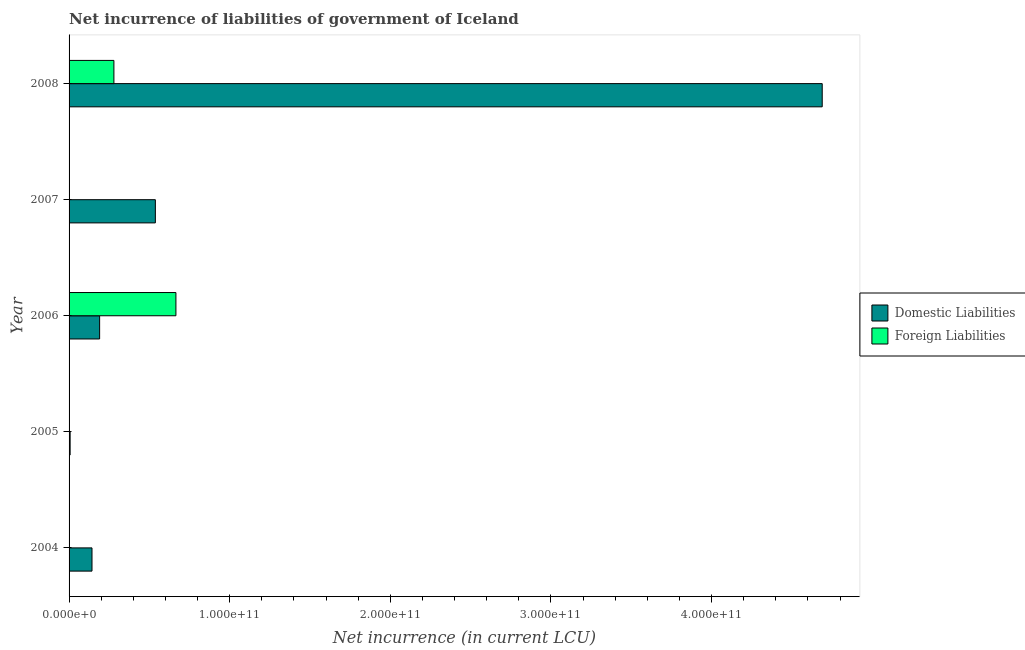Are the number of bars per tick equal to the number of legend labels?
Your answer should be compact. No. Are the number of bars on each tick of the Y-axis equal?
Provide a short and direct response. No. How many bars are there on the 3rd tick from the top?
Make the answer very short. 2. How many bars are there on the 2nd tick from the bottom?
Your response must be concise. 1. What is the net incurrence of domestic liabilities in 2007?
Make the answer very short. 5.37e+1. Across all years, what is the maximum net incurrence of foreign liabilities?
Make the answer very short. 6.65e+1. Across all years, what is the minimum net incurrence of domestic liabilities?
Your answer should be very brief. 6.52e+08. What is the total net incurrence of foreign liabilities in the graph?
Keep it short and to the point. 9.44e+1. What is the difference between the net incurrence of domestic liabilities in 2006 and that in 2007?
Offer a very short reply. -3.47e+1. What is the difference between the net incurrence of domestic liabilities in 2004 and the net incurrence of foreign liabilities in 2008?
Provide a succinct answer. -1.36e+1. What is the average net incurrence of domestic liabilities per year?
Make the answer very short. 1.11e+11. In the year 2008, what is the difference between the net incurrence of domestic liabilities and net incurrence of foreign liabilities?
Your response must be concise. 4.41e+11. What is the ratio of the net incurrence of foreign liabilities in 2006 to that in 2008?
Your answer should be compact. 2.38. Is the net incurrence of domestic liabilities in 2004 less than that in 2006?
Offer a very short reply. Yes. Is the difference between the net incurrence of foreign liabilities in 2006 and 2008 greater than the difference between the net incurrence of domestic liabilities in 2006 and 2008?
Provide a short and direct response. Yes. What is the difference between the highest and the second highest net incurrence of domestic liabilities?
Give a very brief answer. 4.15e+11. What is the difference between the highest and the lowest net incurrence of foreign liabilities?
Provide a short and direct response. 6.65e+1. Are all the bars in the graph horizontal?
Your answer should be very brief. Yes. What is the difference between two consecutive major ticks on the X-axis?
Keep it short and to the point. 1.00e+11. Does the graph contain any zero values?
Your response must be concise. Yes. Where does the legend appear in the graph?
Ensure brevity in your answer.  Center right. What is the title of the graph?
Your answer should be compact. Net incurrence of liabilities of government of Iceland. Does "Private consumption" appear as one of the legend labels in the graph?
Offer a terse response. No. What is the label or title of the X-axis?
Your response must be concise. Net incurrence (in current LCU). What is the Net incurrence (in current LCU) in Domestic Liabilities in 2004?
Make the answer very short. 1.43e+1. What is the Net incurrence (in current LCU) of Foreign Liabilities in 2004?
Your response must be concise. 0. What is the Net incurrence (in current LCU) of Domestic Liabilities in 2005?
Give a very brief answer. 6.52e+08. What is the Net incurrence (in current LCU) in Domestic Liabilities in 2006?
Provide a succinct answer. 1.90e+1. What is the Net incurrence (in current LCU) of Foreign Liabilities in 2006?
Ensure brevity in your answer.  6.65e+1. What is the Net incurrence (in current LCU) in Domestic Liabilities in 2007?
Provide a short and direct response. 5.37e+1. What is the Net incurrence (in current LCU) of Domestic Liabilities in 2008?
Offer a terse response. 4.69e+11. What is the Net incurrence (in current LCU) of Foreign Liabilities in 2008?
Ensure brevity in your answer.  2.79e+1. Across all years, what is the maximum Net incurrence (in current LCU) in Domestic Liabilities?
Your answer should be compact. 4.69e+11. Across all years, what is the maximum Net incurrence (in current LCU) of Foreign Liabilities?
Give a very brief answer. 6.65e+1. Across all years, what is the minimum Net incurrence (in current LCU) in Domestic Liabilities?
Make the answer very short. 6.52e+08. What is the total Net incurrence (in current LCU) in Domestic Liabilities in the graph?
Ensure brevity in your answer.  5.57e+11. What is the total Net incurrence (in current LCU) in Foreign Liabilities in the graph?
Offer a very short reply. 9.44e+1. What is the difference between the Net incurrence (in current LCU) in Domestic Liabilities in 2004 and that in 2005?
Offer a very short reply. 1.36e+1. What is the difference between the Net incurrence (in current LCU) of Domestic Liabilities in 2004 and that in 2006?
Make the answer very short. -4.75e+09. What is the difference between the Net incurrence (in current LCU) in Domestic Liabilities in 2004 and that in 2007?
Provide a succinct answer. -3.95e+1. What is the difference between the Net incurrence (in current LCU) of Domestic Liabilities in 2004 and that in 2008?
Give a very brief answer. -4.55e+11. What is the difference between the Net incurrence (in current LCU) of Domestic Liabilities in 2005 and that in 2006?
Make the answer very short. -1.84e+1. What is the difference between the Net incurrence (in current LCU) of Domestic Liabilities in 2005 and that in 2007?
Provide a short and direct response. -5.31e+1. What is the difference between the Net incurrence (in current LCU) of Domestic Liabilities in 2005 and that in 2008?
Offer a terse response. -4.68e+11. What is the difference between the Net incurrence (in current LCU) in Domestic Liabilities in 2006 and that in 2007?
Make the answer very short. -3.47e+1. What is the difference between the Net incurrence (in current LCU) of Domestic Liabilities in 2006 and that in 2008?
Ensure brevity in your answer.  -4.50e+11. What is the difference between the Net incurrence (in current LCU) in Foreign Liabilities in 2006 and that in 2008?
Offer a terse response. 3.86e+1. What is the difference between the Net incurrence (in current LCU) in Domestic Liabilities in 2007 and that in 2008?
Your response must be concise. -4.15e+11. What is the difference between the Net incurrence (in current LCU) in Domestic Liabilities in 2004 and the Net incurrence (in current LCU) in Foreign Liabilities in 2006?
Provide a succinct answer. -5.23e+1. What is the difference between the Net incurrence (in current LCU) of Domestic Liabilities in 2004 and the Net incurrence (in current LCU) of Foreign Liabilities in 2008?
Offer a very short reply. -1.36e+1. What is the difference between the Net incurrence (in current LCU) in Domestic Liabilities in 2005 and the Net incurrence (in current LCU) in Foreign Liabilities in 2006?
Offer a terse response. -6.59e+1. What is the difference between the Net incurrence (in current LCU) in Domestic Liabilities in 2005 and the Net incurrence (in current LCU) in Foreign Liabilities in 2008?
Keep it short and to the point. -2.73e+1. What is the difference between the Net incurrence (in current LCU) of Domestic Liabilities in 2006 and the Net incurrence (in current LCU) of Foreign Liabilities in 2008?
Offer a very short reply. -8.90e+09. What is the difference between the Net incurrence (in current LCU) of Domestic Liabilities in 2007 and the Net incurrence (in current LCU) of Foreign Liabilities in 2008?
Ensure brevity in your answer.  2.58e+1. What is the average Net incurrence (in current LCU) in Domestic Liabilities per year?
Your answer should be compact. 1.11e+11. What is the average Net incurrence (in current LCU) of Foreign Liabilities per year?
Your response must be concise. 1.89e+1. In the year 2006, what is the difference between the Net incurrence (in current LCU) of Domestic Liabilities and Net incurrence (in current LCU) of Foreign Liabilities?
Provide a short and direct response. -4.75e+1. In the year 2008, what is the difference between the Net incurrence (in current LCU) in Domestic Liabilities and Net incurrence (in current LCU) in Foreign Liabilities?
Offer a very short reply. 4.41e+11. What is the ratio of the Net incurrence (in current LCU) of Domestic Liabilities in 2004 to that in 2005?
Ensure brevity in your answer.  21.9. What is the ratio of the Net incurrence (in current LCU) of Domestic Liabilities in 2004 to that in 2006?
Your answer should be very brief. 0.75. What is the ratio of the Net incurrence (in current LCU) of Domestic Liabilities in 2004 to that in 2007?
Give a very brief answer. 0.27. What is the ratio of the Net incurrence (in current LCU) of Domestic Liabilities in 2004 to that in 2008?
Provide a succinct answer. 0.03. What is the ratio of the Net incurrence (in current LCU) in Domestic Liabilities in 2005 to that in 2006?
Provide a succinct answer. 0.03. What is the ratio of the Net incurrence (in current LCU) in Domestic Liabilities in 2005 to that in 2007?
Ensure brevity in your answer.  0.01. What is the ratio of the Net incurrence (in current LCU) of Domestic Liabilities in 2005 to that in 2008?
Provide a short and direct response. 0. What is the ratio of the Net incurrence (in current LCU) of Domestic Liabilities in 2006 to that in 2007?
Give a very brief answer. 0.35. What is the ratio of the Net incurrence (in current LCU) in Domestic Liabilities in 2006 to that in 2008?
Your answer should be very brief. 0.04. What is the ratio of the Net incurrence (in current LCU) of Foreign Liabilities in 2006 to that in 2008?
Offer a very short reply. 2.38. What is the ratio of the Net incurrence (in current LCU) in Domestic Liabilities in 2007 to that in 2008?
Provide a short and direct response. 0.11. What is the difference between the highest and the second highest Net incurrence (in current LCU) in Domestic Liabilities?
Provide a short and direct response. 4.15e+11. What is the difference between the highest and the lowest Net incurrence (in current LCU) in Domestic Liabilities?
Provide a succinct answer. 4.68e+11. What is the difference between the highest and the lowest Net incurrence (in current LCU) in Foreign Liabilities?
Your response must be concise. 6.65e+1. 